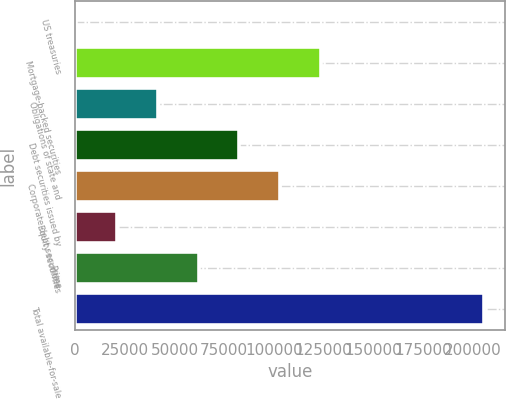Convert chart to OTSL. <chart><loc_0><loc_0><loc_500><loc_500><bar_chart><fcel>US treasuries<fcel>Mortgage-backed securities<fcel>Obligations of state and<fcel>Debt securities issued by<fcel>Corporate debt securities<fcel>Equity securities<fcel>Prime<fcel>Total available-for-sale<nl><fcel>611<fcel>123790<fcel>41670.6<fcel>82730.2<fcel>103260<fcel>21140.8<fcel>62200.4<fcel>205909<nl></chart> 